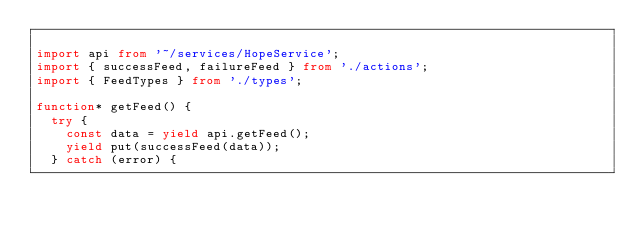Convert code to text. <code><loc_0><loc_0><loc_500><loc_500><_TypeScript_>
import api from '~/services/HopeService';
import { successFeed, failureFeed } from './actions';
import { FeedTypes } from './types';

function* getFeed() {
  try {
    const data = yield api.getFeed();
    yield put(successFeed(data));
  } catch (error) {</code> 